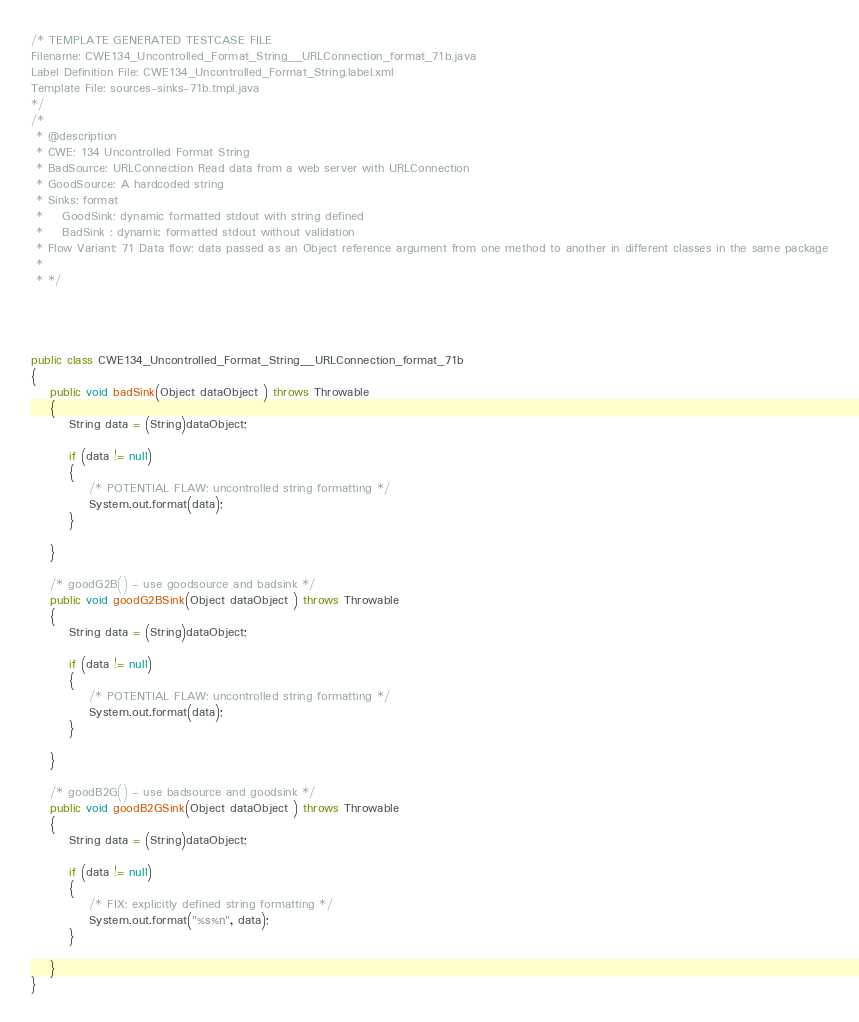Convert code to text. <code><loc_0><loc_0><loc_500><loc_500><_Java_>/* TEMPLATE GENERATED TESTCASE FILE
Filename: CWE134_Uncontrolled_Format_String__URLConnection_format_71b.java
Label Definition File: CWE134_Uncontrolled_Format_String.label.xml
Template File: sources-sinks-71b.tmpl.java
*/
/*
 * @description
 * CWE: 134 Uncontrolled Format String
 * BadSource: URLConnection Read data from a web server with URLConnection
 * GoodSource: A hardcoded string
 * Sinks: format
 *    GoodSink: dynamic formatted stdout with string defined
 *    BadSink : dynamic formatted stdout without validation
 * Flow Variant: 71 Data flow: data passed as an Object reference argument from one method to another in different classes in the same package
 *
 * */




public class CWE134_Uncontrolled_Format_String__URLConnection_format_71b
{
    public void badSink(Object dataObject ) throws Throwable
    {
        String data = (String)dataObject;

        if (data != null)
        {
            /* POTENTIAL FLAW: uncontrolled string formatting */
            System.out.format(data);
        }

    }

    /* goodG2B() - use goodsource and badsink */
    public void goodG2BSink(Object dataObject ) throws Throwable
    {
        String data = (String)dataObject;

        if (data != null)
        {
            /* POTENTIAL FLAW: uncontrolled string formatting */
            System.out.format(data);
        }

    }

    /* goodB2G() - use badsource and goodsink */
    public void goodB2GSink(Object dataObject ) throws Throwable
    {
        String data = (String)dataObject;

        if (data != null)
        {
            /* FIX: explicitly defined string formatting */
            System.out.format("%s%n", data);
        }

    }
}
</code> 